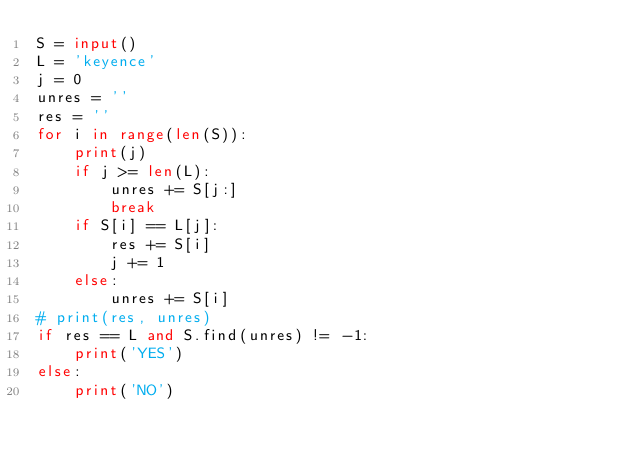<code> <loc_0><loc_0><loc_500><loc_500><_Python_>S = input()
L = 'keyence'
j = 0
unres = ''
res = ''
for i in range(len(S)):
    print(j)
    if j >= len(L):
        unres += S[j:]
        break
    if S[i] == L[j]:
        res += S[i]
        j += 1
    else:
        unres += S[i]
# print(res, unres)
if res == L and S.find(unres) != -1:
    print('YES')
else:
    print('NO')
</code> 